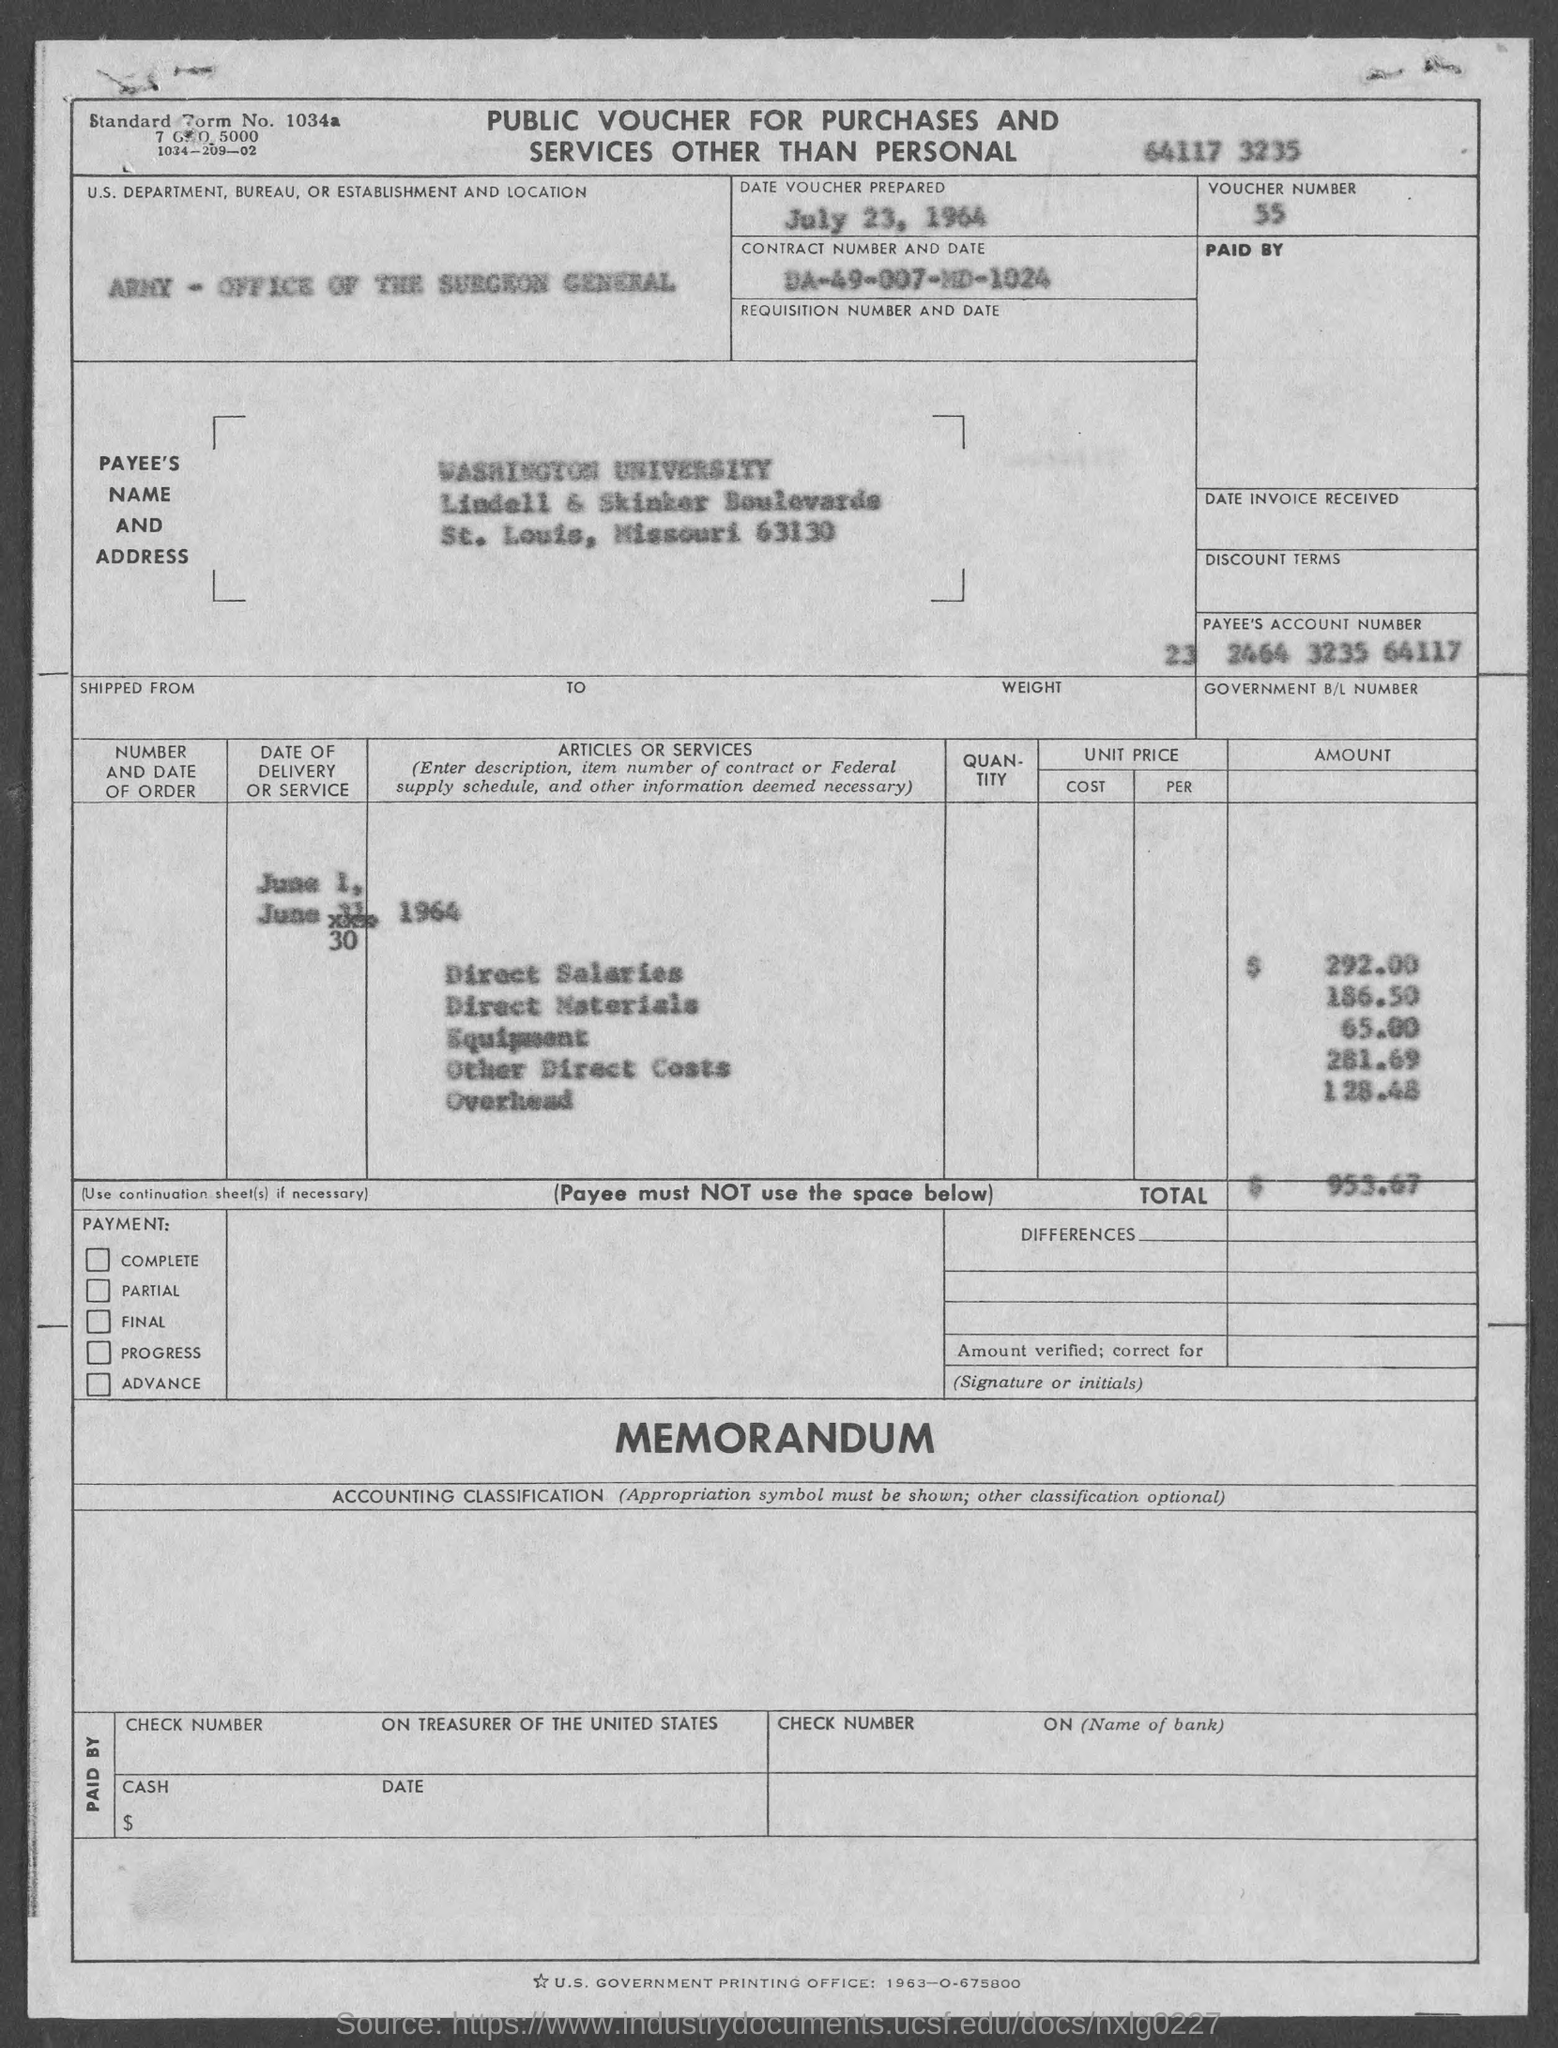Specify some key components in this picture. The direct salaries cost mentioned in the voucher is 292.00. The voucher was prepared on July 23, 1964. The standard form number listed in the voucher is 1034a... The payee name listed in the voucher is "Washington University. The payee's account number, as indicated in the voucher, is 232464323564117. 